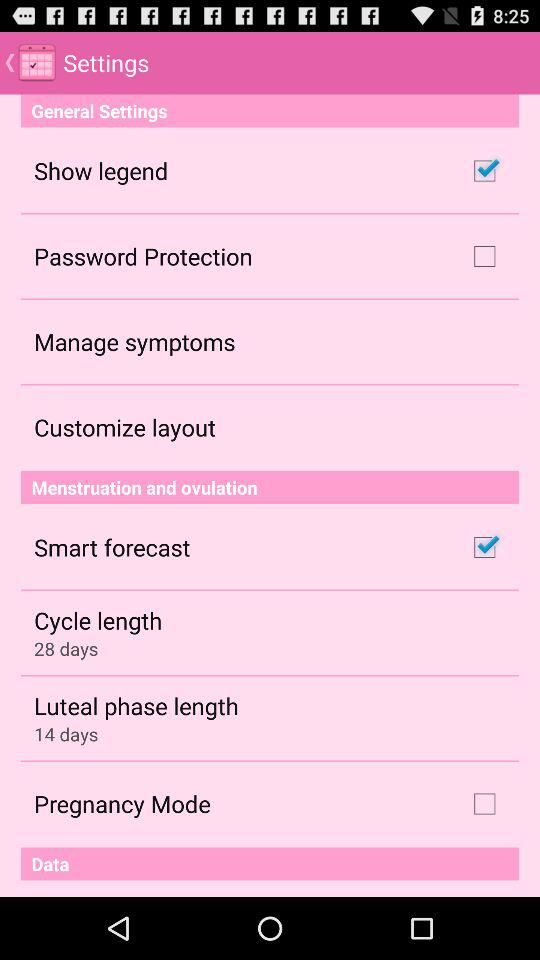What is the luteal phase length? The luteal phase length is 14 days. 